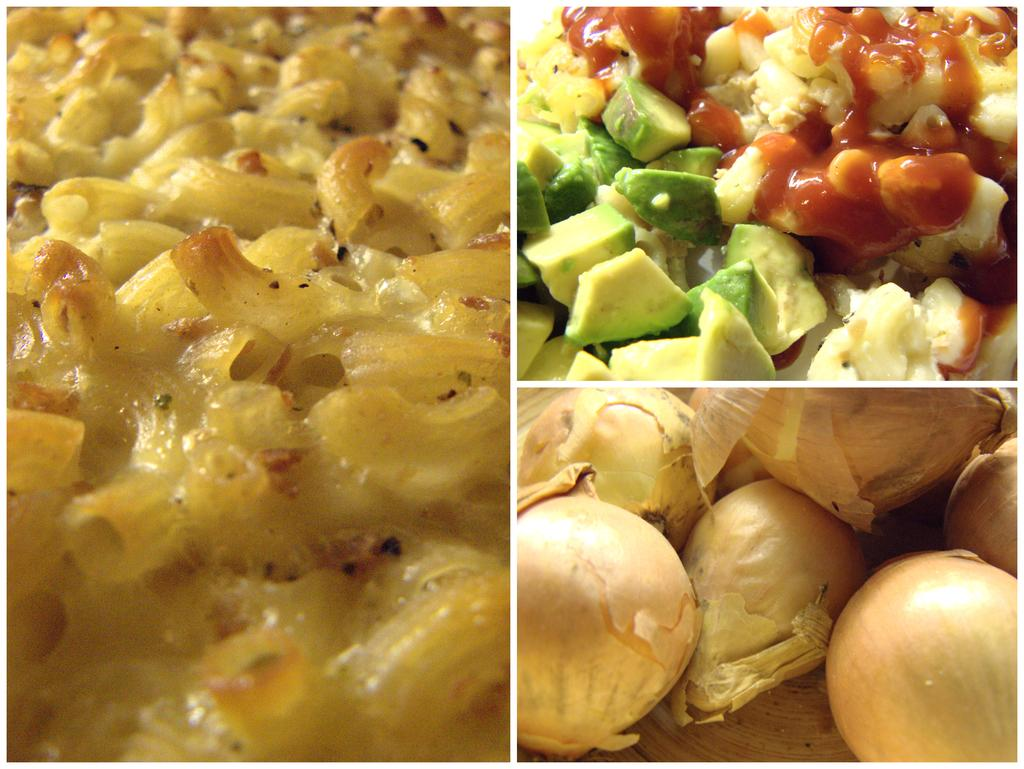What is the format of the image? The image is a collage of three different pictures. What type of objects are featured in each picture of the collage? Each picture in the collage contains food items. Can you see a flock of chickens in any of the pictures in the collage? There is no flock of chickens present in any of the pictures in the collage. What type of paste is being used to prepare the food items in the pictures? There is no specific type of paste mentioned or visible in the pictures; they only show various food items. 